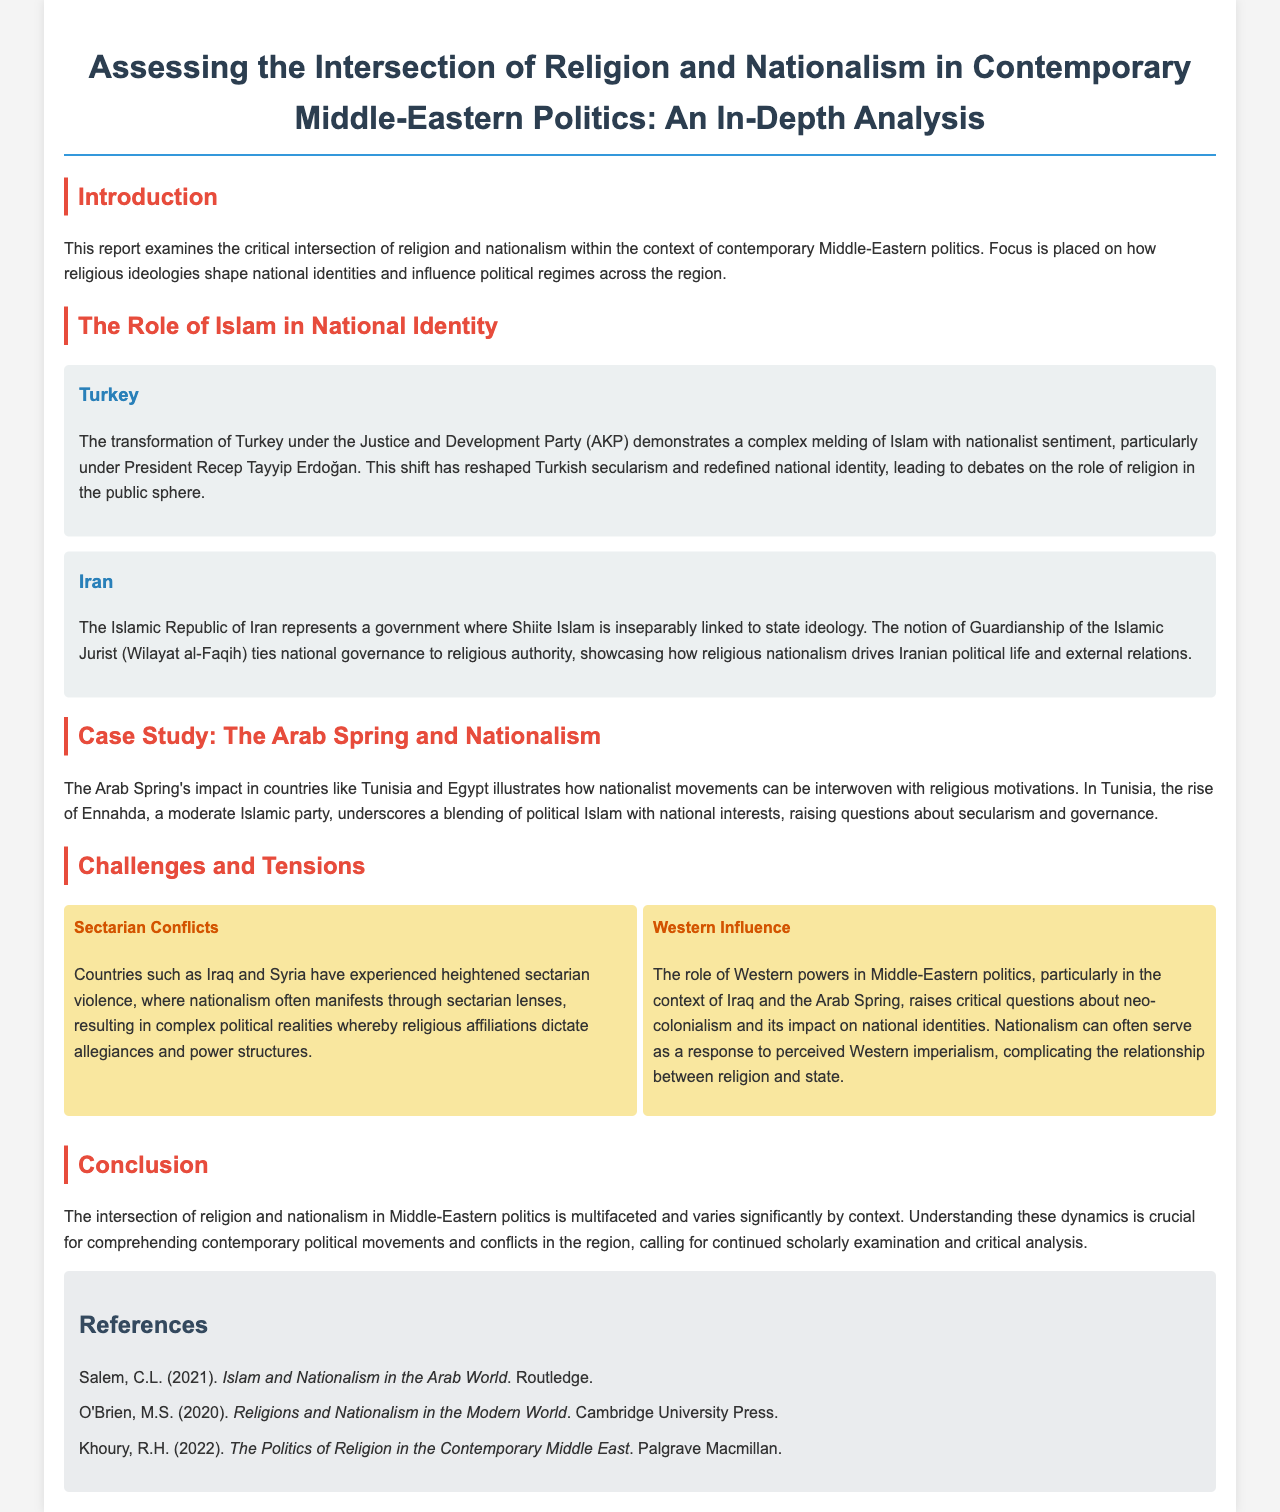What is the title of the report? The title is specified at the beginning of the document.
Answer: Assessing the Intersection of Religion and Nationalism in Contemporary Middle-Eastern Politics: An In-Depth Analysis Who is the President mentioned in the Turkey case study? The case study on Turkey identifies a significant political figure, the President.
Answer: Recep Tayyip Erdoğan What concept ties national governance to religious authority in Iran? The document explains a central religious-political concept related to Iran.
Answer: Guardianship of the Islamic Jurist Which party rose in Tunisia during the Arab Spring? The report highlights a political party that gained prominence in Tunisia.
Answer: Ennahda What do the issues of sectarian conflicts and Western influence represent in the document? These issues are discussed as significant challenges in the intersection of religion and nationalism.
Answer: Challenges How many references are listed in the report? The document includes a section with references detailing the number provided.
Answer: Three What is a major theme of the conclusion? The conclusion summarizes a critical aspect of the analysis regarding Middle-Eastern politics.
Answer: Intersection of religion and nationalism What type of ideology is linked to the Islamic Republic of Iran? This ideology is discussed concerning state governance and societal structures.
Answer: Shiite Islam 